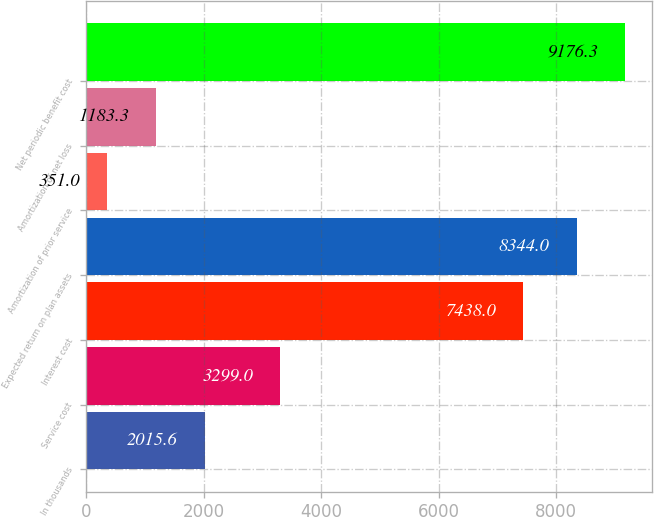<chart> <loc_0><loc_0><loc_500><loc_500><bar_chart><fcel>In thousands<fcel>Service cost<fcel>Interest cost<fcel>Expected return on plan assets<fcel>Amortization of prior service<fcel>Amortization of net loss<fcel>Net periodic benefit cost<nl><fcel>2015.6<fcel>3299<fcel>7438<fcel>8344<fcel>351<fcel>1183.3<fcel>9176.3<nl></chart> 